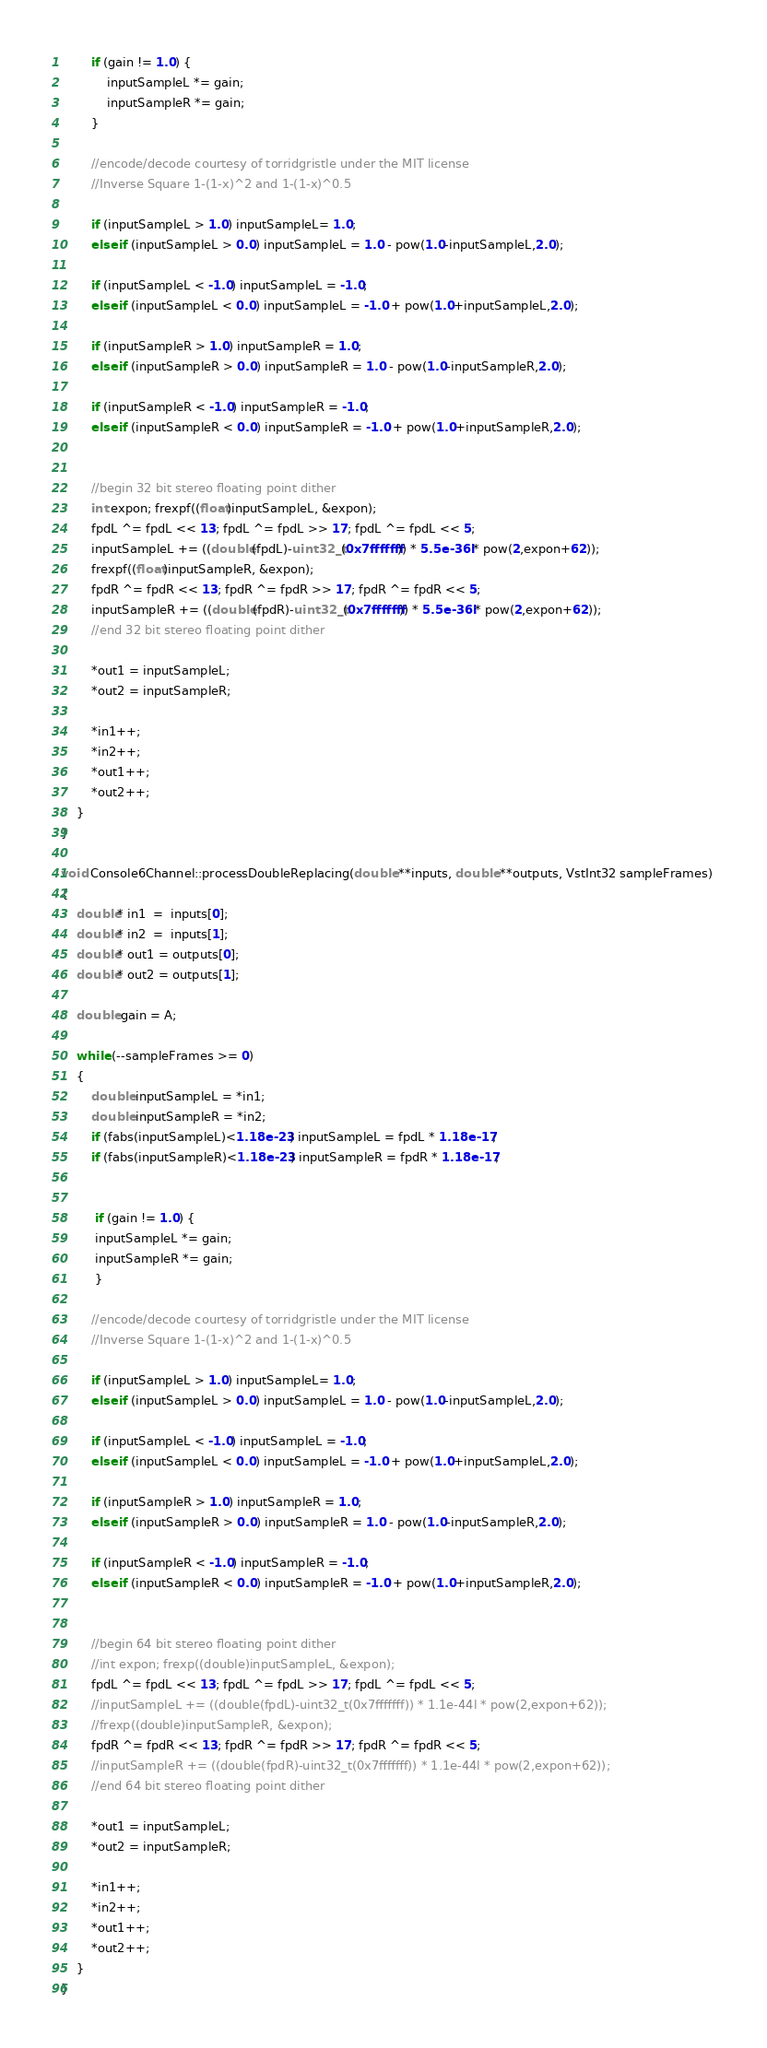Convert code to text. <code><loc_0><loc_0><loc_500><loc_500><_C++_>		if (gain != 1.0) {
			inputSampleL *= gain;
			inputSampleR *= gain;
		}		
		
		//encode/decode courtesy of torridgristle under the MIT license
		//Inverse Square 1-(1-x)^2 and 1-(1-x)^0.5
		
		if (inputSampleL > 1.0) inputSampleL= 1.0;
		else if (inputSampleL > 0.0) inputSampleL = 1.0 - pow(1.0-inputSampleL,2.0);
		
		if (inputSampleL < -1.0) inputSampleL = -1.0;
		else if (inputSampleL < 0.0) inputSampleL = -1.0 + pow(1.0+inputSampleL,2.0);
		
		if (inputSampleR > 1.0) inputSampleR = 1.0;
		else if (inputSampleR > 0.0) inputSampleR = 1.0 - pow(1.0-inputSampleR,2.0);
		
		if (inputSampleR < -1.0) inputSampleR = -1.0;
		else if (inputSampleR < 0.0) inputSampleR = -1.0 + pow(1.0+inputSampleR,2.0);
		
		
		//begin 32 bit stereo floating point dither
		int expon; frexpf((float)inputSampleL, &expon);
		fpdL ^= fpdL << 13; fpdL ^= fpdL >> 17; fpdL ^= fpdL << 5;
		inputSampleL += ((double(fpdL)-uint32_t(0x7fffffff)) * 5.5e-36l * pow(2,expon+62));
		frexpf((float)inputSampleR, &expon);
		fpdR ^= fpdR << 13; fpdR ^= fpdR >> 17; fpdR ^= fpdR << 5;
		inputSampleR += ((double(fpdR)-uint32_t(0x7fffffff)) * 5.5e-36l * pow(2,expon+62));
		//end 32 bit stereo floating point dither
		
		*out1 = inputSampleL;
		*out2 = inputSampleR;

		*in1++;
		*in2++;
		*out1++;
		*out2++;
    }
}

void Console6Channel::processDoubleReplacing(double **inputs, double **outputs, VstInt32 sampleFrames) 
{
    double* in1  =  inputs[0];
    double* in2  =  inputs[1];
    double* out1 = outputs[0];
    double* out2 = outputs[1];

	double gain = A;

    while (--sampleFrames >= 0)
    {
		double inputSampleL = *in1;
		double inputSampleR = *in2;
		if (fabs(inputSampleL)<1.18e-23) inputSampleL = fpdL * 1.18e-17;
		if (fabs(inputSampleR)<1.18e-23) inputSampleR = fpdR * 1.18e-17;

		
		 if (gain != 1.0) {
		 inputSampleL *= gain;
		 inputSampleR *= gain;
		 }		
		 
		//encode/decode courtesy of torridgristle under the MIT license
		//Inverse Square 1-(1-x)^2 and 1-(1-x)^0.5
		
		if (inputSampleL > 1.0) inputSampleL= 1.0;
		else if (inputSampleL > 0.0) inputSampleL = 1.0 - pow(1.0-inputSampleL,2.0);
		
		if (inputSampleL < -1.0) inputSampleL = -1.0;
		else if (inputSampleL < 0.0) inputSampleL = -1.0 + pow(1.0+inputSampleL,2.0);
				
		if (inputSampleR > 1.0) inputSampleR = 1.0;
		else if (inputSampleR > 0.0) inputSampleR = 1.0 - pow(1.0-inputSampleR,2.0);
		
		if (inputSampleR < -1.0) inputSampleR = -1.0;
		else if (inputSampleR < 0.0) inputSampleR = -1.0 + pow(1.0+inputSampleR,2.0);
		
		
		//begin 64 bit stereo floating point dither
		//int expon; frexp((double)inputSampleL, &expon);
		fpdL ^= fpdL << 13; fpdL ^= fpdL >> 17; fpdL ^= fpdL << 5;
		//inputSampleL += ((double(fpdL)-uint32_t(0x7fffffff)) * 1.1e-44l * pow(2,expon+62));
		//frexp((double)inputSampleR, &expon);
		fpdR ^= fpdR << 13; fpdR ^= fpdR >> 17; fpdR ^= fpdR << 5;
		//inputSampleR += ((double(fpdR)-uint32_t(0x7fffffff)) * 1.1e-44l * pow(2,expon+62));
		//end 64 bit stereo floating point dither
		
		*out1 = inputSampleL;
		*out2 = inputSampleR;

		*in1++;
		*in2++;
		*out1++;
		*out2++;
    }
}
</code> 